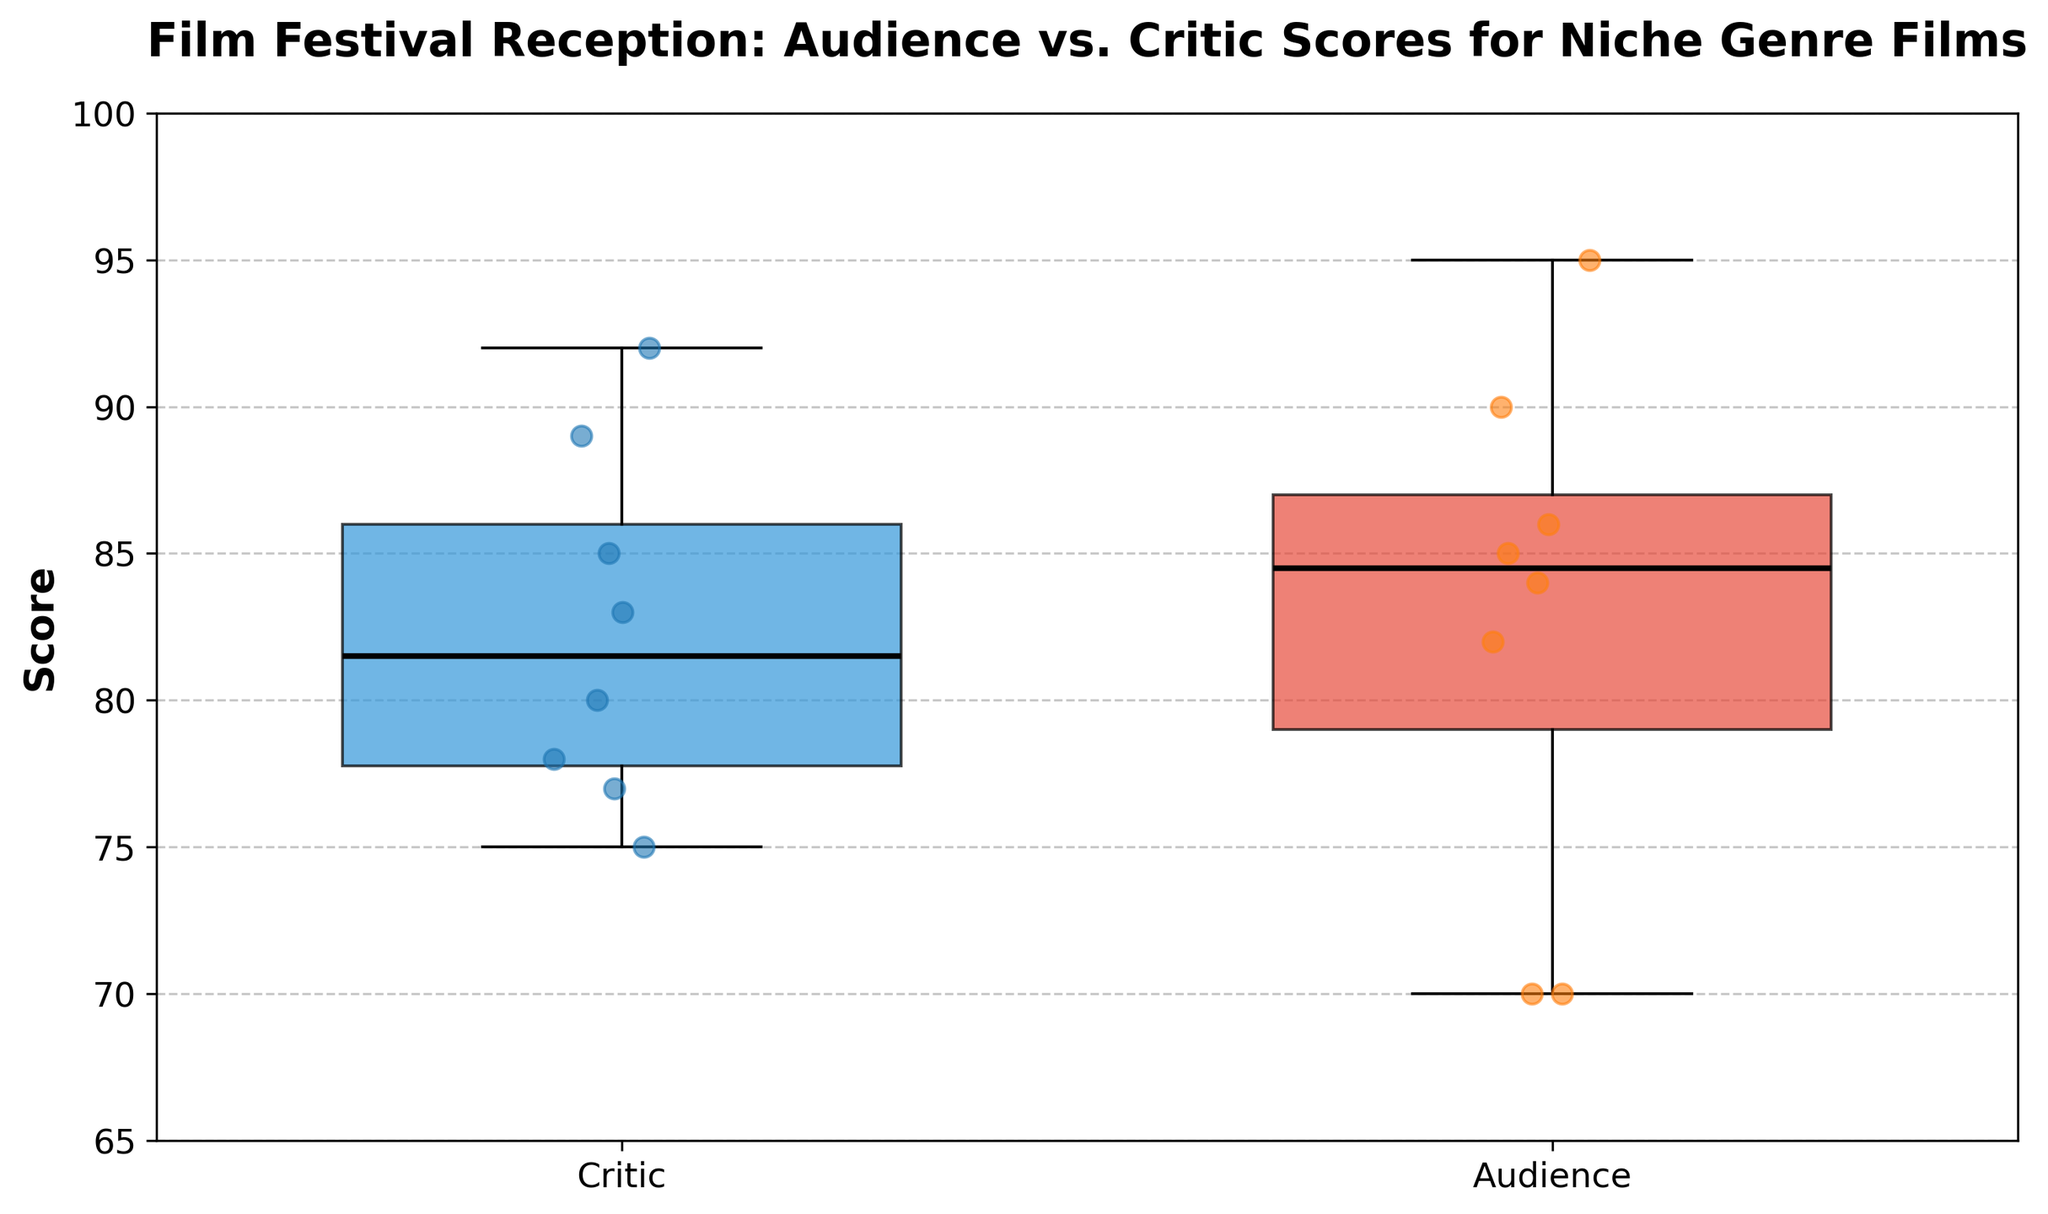what is the title of the plot? The title is text at the top of the figure that provides a brief description of what the plot is illustrating, often in bold and larger font than other text. The title of the plot helps viewers quickly understand the subject of the visualization.
Answer: Film Festival Reception: Audience vs. Critic Scores for Niche Genre Films what are the labels on the x-axis? The x-axis labels indicate the two groups being compared in the box plot. These labels help readers identify which data corresponds to which group. The labels on the x-axis of this figure are located beneath each box plot.
Answer: Critic, Audience what is the range of scores shown on the y-axis? The range of scores is determined by the lowest and highest values on the y-axis, providing a context for where the data points lie. This range is set by the y-axis limits shown on the y-axis line.
Answer: 65 to 100 which group has the higher median score? The median score is represented by the black horizontal line inside each box. By comparing the positions of these lines, the group with the higher line has the higher median score.
Answer: Critic are the range of audience scores wider or narrower compared to critic scores? The range of scores for each group is represented by the span of the boxes and the lines extending from them (whiskers). Comparing these spans will tell us which group has a wider range of scores.
Answer: Wider are there any outliers and if so, in which group(s)? Outliers in a box plot are represented by individual points outside the whiskers. These points indicate data that deviates significantly from the central range of the data. By checking both groups, we can see where outliers are located.
Answer: Audience by how much does the highest audience score exceed the highest critic score? Identifying the highest data point in both groups and subtracting the highest critic score from the highest audience score will give us the difference between them. The highest audience score is 95 and the highest critic score is 92, so the calculation is 95 - 92 = 3.
Answer: 3 which group shows a lower variability in scores and how can you tell? Variability in scores can be inferred from the interquartile range (IQR), represented by the height of the boxes. The group with the smaller IQR (shorter box) shows lower variability in scores. In this figure, by comparing the heights of the boxes, we can see that the critic scores show lower variability.
Answer: Critic are there any overlapping score ranges between the groups? Overlapping score ranges occur when the whiskers (and possibly the boxes) of both groups extend into the same y-axis range. By examining the figure, we can see if the ranges covered by the whiskers of one group also appear within the range of the other group's whiskers.
Answer: Yes is the overall audience reception more positive or negative compared to critic reception? This can be determined by comparing both the median scores and the overall spread of the data points. Since we consider higher scores to be more positive and look at median levels and spread, we notice that while the median critic score (around 80-85) is lower than the median audience score (near 85-90), the wider spread and higher max suggests a slightly more positive reception by the audience.
Answer: More positive 